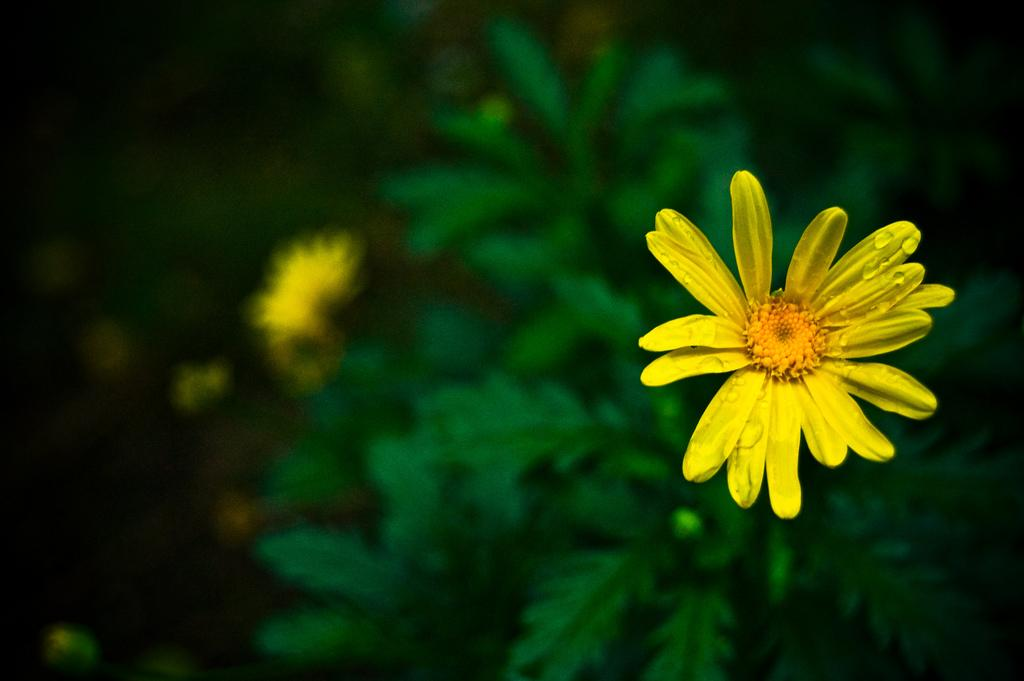What type of flower is in the image? There is a yellow flower in the image. What other parts of the flower can be seen besides the petals? The flower has leaves. How would you describe the overall appearance of the image? The background of the image appears slightly blurred. What type of bait is used to catch the instrument in the middle of the image? There is no bait or instrument present in the image; it features a yellow flower with leaves. 